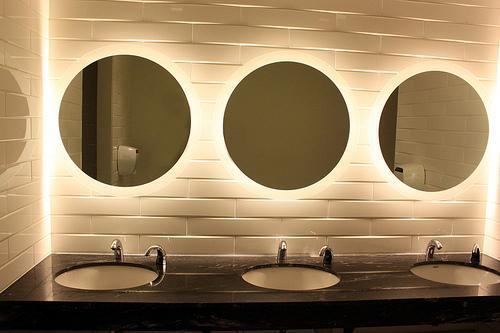How many sinks are shown?
Give a very brief answer. 3. 